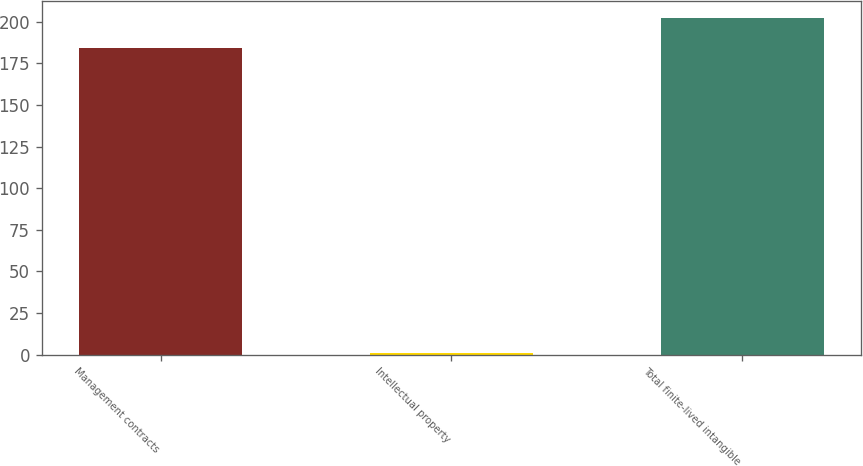<chart> <loc_0><loc_0><loc_500><loc_500><bar_chart><fcel>Management contracts<fcel>Intellectual property<fcel>Total finite-lived intangible<nl><fcel>184<fcel>1<fcel>202.4<nl></chart> 